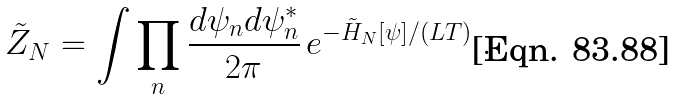Convert formula to latex. <formula><loc_0><loc_0><loc_500><loc_500>\tilde { Z } _ { N } = \int \prod _ { n } \frac { d \psi _ { n } d \psi ^ { * } _ { n } } { 2 \pi } \, e ^ { { - \tilde { H } _ { N } } [ \psi ] / ( L T ) } \ .</formula> 